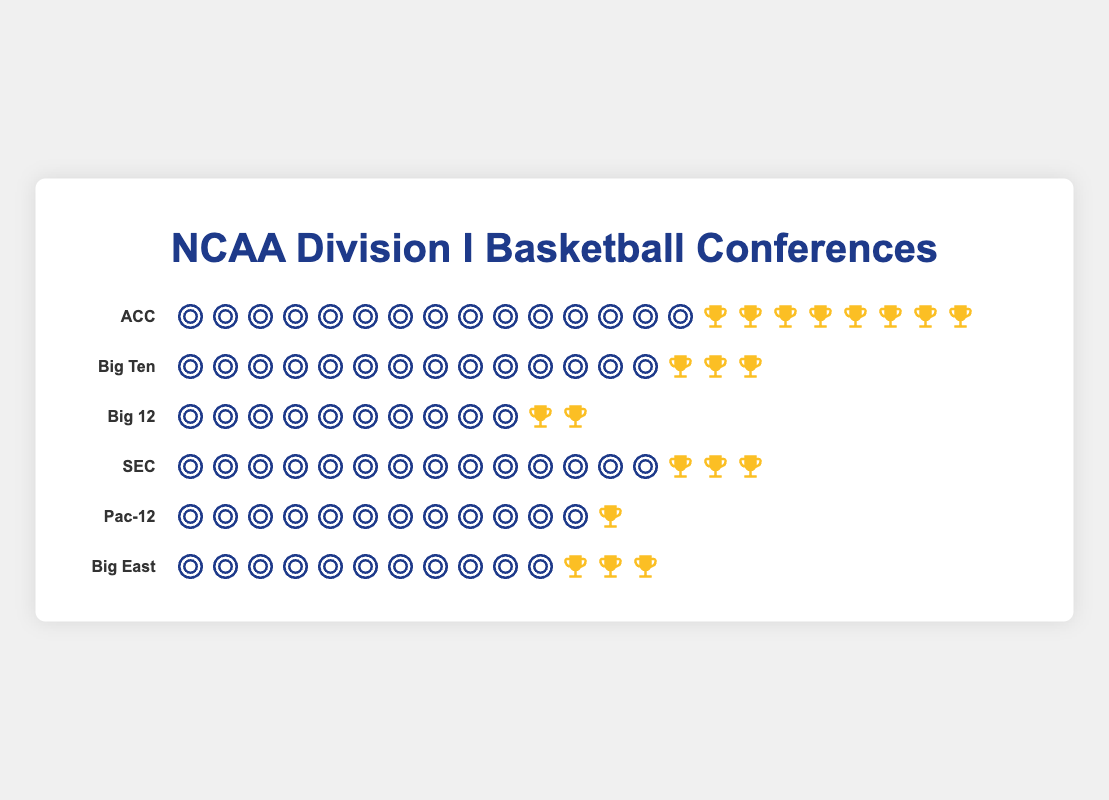Which conference has the most teams? The ACC conference has the most teams. By counting the team icons in each row, we see that the ACC has 15 teams, which is the highest among the listed conferences.
Answer: ACC How many championships have the Big Ten and SEC conferences won together? The Big Ten has 3 championships and the SEC has also won 3 championships. Adding these together gives 3 + 3 = 6.
Answer: 6 Which conference has the fewest championships? The Pac-12 conference has the fewest championships. From the trophy icons, the Pac-12 has only 1 championship.
Answer: Pac-12 How many more teams does the Big Ten have compared to the Big 12? Count the team icons for each conference: the Big Ten has 14 teams, while the Big 12 has 10 teams. Subtracting these gives 14 - 10 = 4.
Answer: 4 Which conference has the fewest teams? The Big 12 conference has the fewest teams. By counting the team icons, Big 12 is shown to have 10 teams.
Answer: Big 12 Which conference has the highest ratio of championships won to the number of teams? Calculate the ratio for each conference by dividing the number of championships by the number of teams and compare:
- ACC: 8/15 = 0.53
- Big Ten: 3/14 = 0.21
- Big 12: 2/10 = 0.2
- SEC: 3/14 = 0.21
- Pac-12: 1/12 = 0.08
- Big East: 3/11 = 0.27
The ACC has the highest ratio of 0.53.
Answer: ACC How many teams are there in total across all conferences? Summing up the number of teams from all conferences: 15 (ACC) + 14 (Big Ten) + 10 (Big 12) + 14 (SEC) + 12 (Pac-12) + 11 (Big East) = 76
Answer: 76 